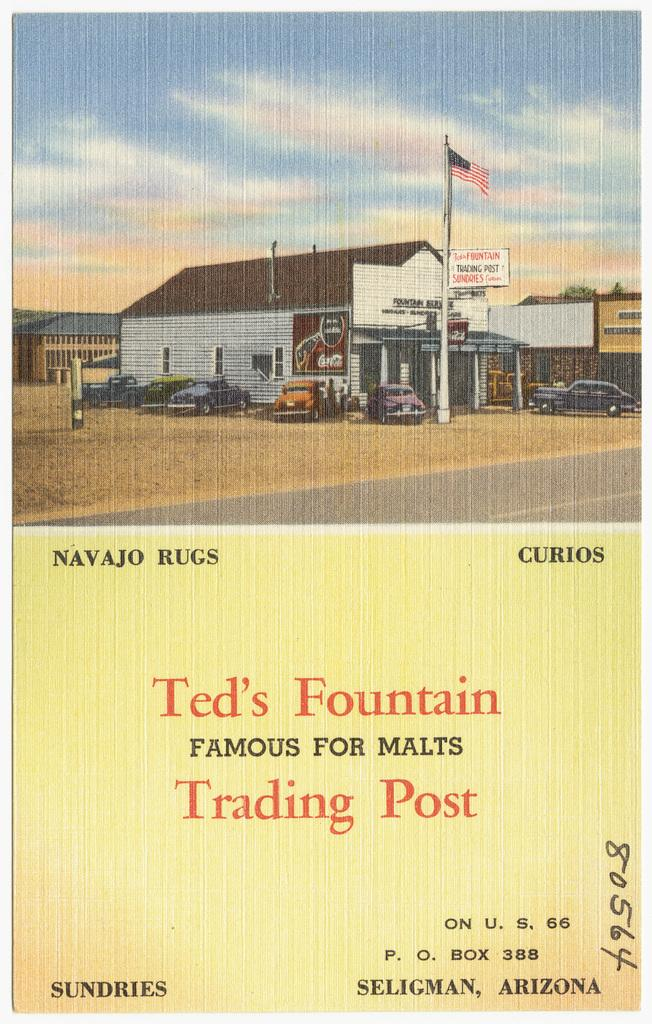<image>
Describe the image concisely. A faded flyer for an old-time trading post called Ted's Fountain. 